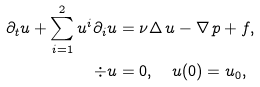<formula> <loc_0><loc_0><loc_500><loc_500>\partial _ { t } u + \sum _ { i = 1 } ^ { 2 } u ^ { i } \partial _ { i } u & = \nu \Delta \, u - \nabla \, p + f , \\ \div u & = 0 , \quad u ( 0 ) = u _ { 0 } ,</formula> 